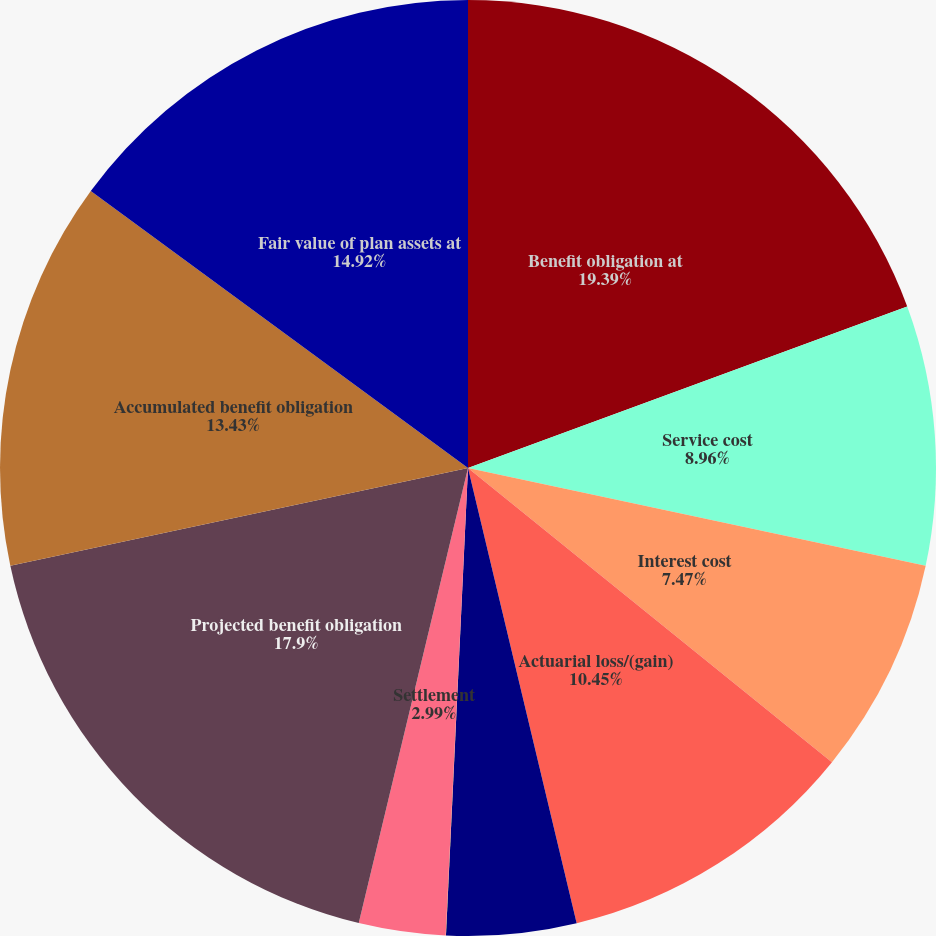Convert chart to OTSL. <chart><loc_0><loc_0><loc_500><loc_500><pie_chart><fcel>Benefit obligation at<fcel>Service cost<fcel>Interest cost<fcel>Actuarial loss/(gain)<fcel>Benefits paid<fcel>Curtailment<fcel>Settlement<fcel>Projected benefit obligation<fcel>Accumulated benefit obligation<fcel>Fair value of plan assets at<nl><fcel>19.39%<fcel>8.96%<fcel>7.47%<fcel>10.45%<fcel>4.48%<fcel>0.01%<fcel>2.99%<fcel>17.9%<fcel>13.43%<fcel>14.92%<nl></chart> 